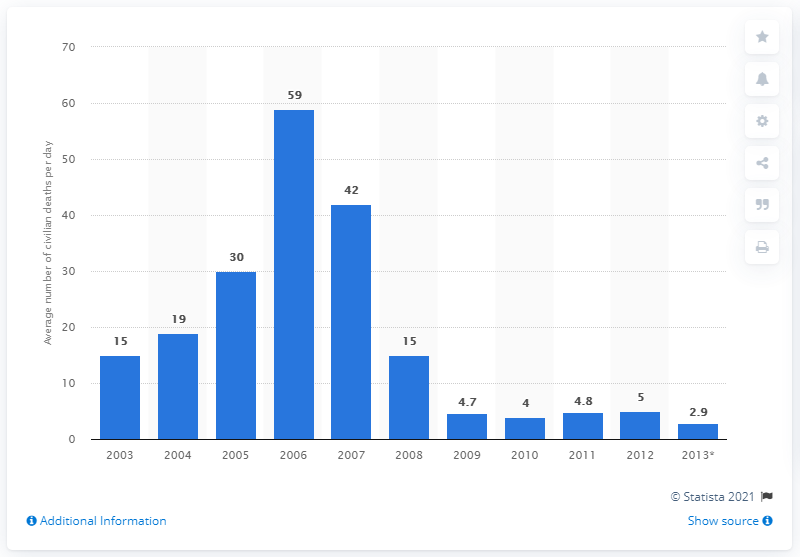Identify some key points in this picture. On January 19, 2013, the average number of civilian deaths per day from gunfire and execution was 2.9. 